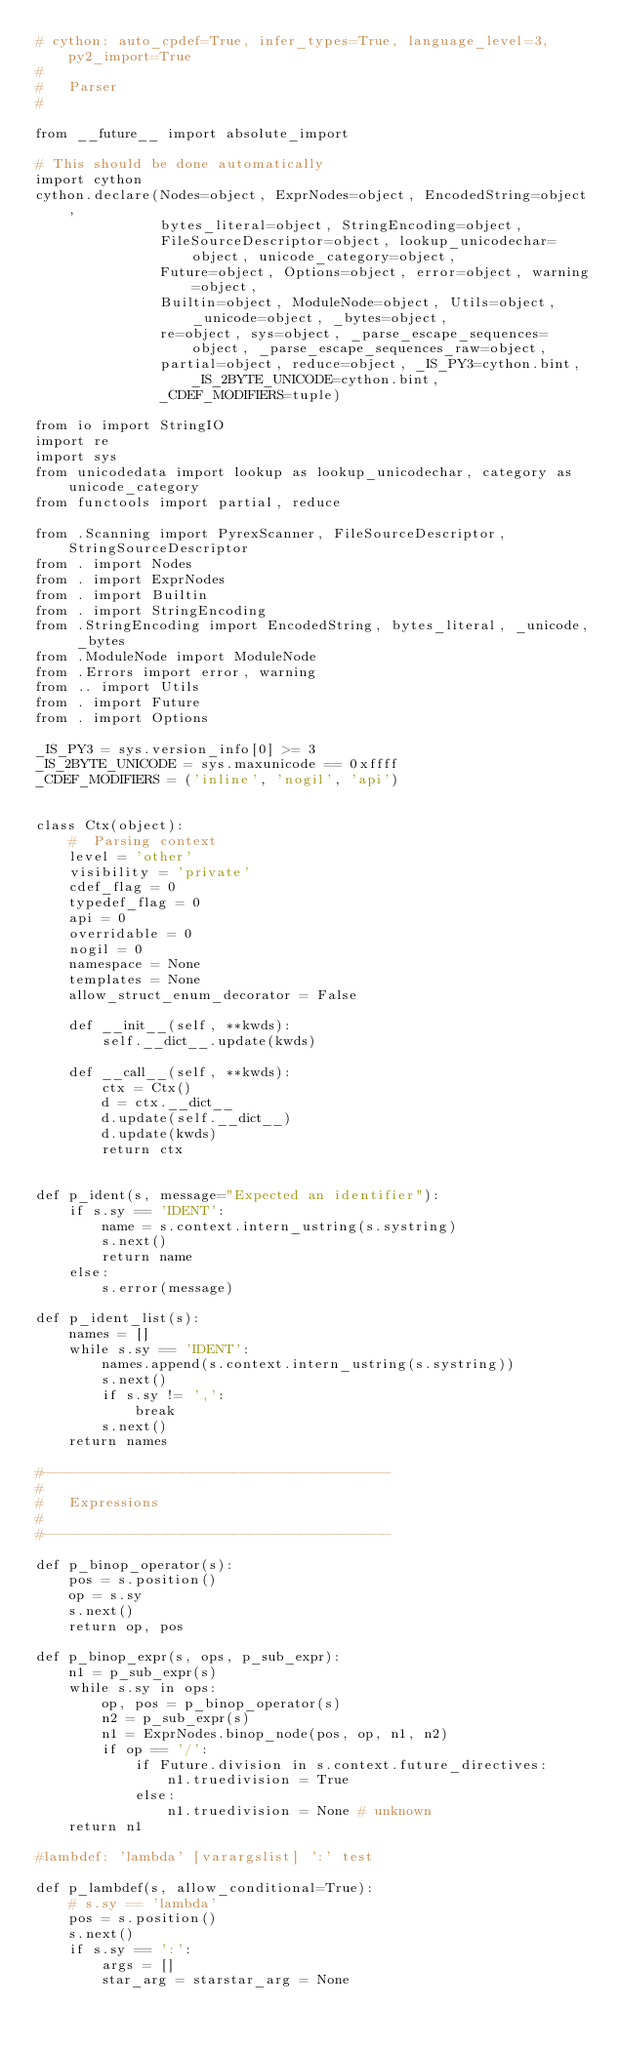Convert code to text. <code><loc_0><loc_0><loc_500><loc_500><_Python_># cython: auto_cpdef=True, infer_types=True, language_level=3, py2_import=True
#
#   Parser
#

from __future__ import absolute_import

# This should be done automatically
import cython
cython.declare(Nodes=object, ExprNodes=object, EncodedString=object,
               bytes_literal=object, StringEncoding=object,
               FileSourceDescriptor=object, lookup_unicodechar=object, unicode_category=object,
               Future=object, Options=object, error=object, warning=object,
               Builtin=object, ModuleNode=object, Utils=object, _unicode=object, _bytes=object,
               re=object, sys=object, _parse_escape_sequences=object, _parse_escape_sequences_raw=object,
               partial=object, reduce=object, _IS_PY3=cython.bint, _IS_2BYTE_UNICODE=cython.bint,
               _CDEF_MODIFIERS=tuple)

from io import StringIO
import re
import sys
from unicodedata import lookup as lookup_unicodechar, category as unicode_category
from functools import partial, reduce

from .Scanning import PyrexScanner, FileSourceDescriptor, StringSourceDescriptor
from . import Nodes
from . import ExprNodes
from . import Builtin
from . import StringEncoding
from .StringEncoding import EncodedString, bytes_literal, _unicode, _bytes
from .ModuleNode import ModuleNode
from .Errors import error, warning
from .. import Utils
from . import Future
from . import Options

_IS_PY3 = sys.version_info[0] >= 3
_IS_2BYTE_UNICODE = sys.maxunicode == 0xffff
_CDEF_MODIFIERS = ('inline', 'nogil', 'api')


class Ctx(object):
    #  Parsing context
    level = 'other'
    visibility = 'private'
    cdef_flag = 0
    typedef_flag = 0
    api = 0
    overridable = 0
    nogil = 0
    namespace = None
    templates = None
    allow_struct_enum_decorator = False

    def __init__(self, **kwds):
        self.__dict__.update(kwds)

    def __call__(self, **kwds):
        ctx = Ctx()
        d = ctx.__dict__
        d.update(self.__dict__)
        d.update(kwds)
        return ctx


def p_ident(s, message="Expected an identifier"):
    if s.sy == 'IDENT':
        name = s.context.intern_ustring(s.systring)
        s.next()
        return name
    else:
        s.error(message)

def p_ident_list(s):
    names = []
    while s.sy == 'IDENT':
        names.append(s.context.intern_ustring(s.systring))
        s.next()
        if s.sy != ',':
            break
        s.next()
    return names

#------------------------------------------
#
#   Expressions
#
#------------------------------------------

def p_binop_operator(s):
    pos = s.position()
    op = s.sy
    s.next()
    return op, pos

def p_binop_expr(s, ops, p_sub_expr):
    n1 = p_sub_expr(s)
    while s.sy in ops:
        op, pos = p_binop_operator(s)
        n2 = p_sub_expr(s)
        n1 = ExprNodes.binop_node(pos, op, n1, n2)
        if op == '/':
            if Future.division in s.context.future_directives:
                n1.truedivision = True
            else:
                n1.truedivision = None # unknown
    return n1

#lambdef: 'lambda' [varargslist] ':' test

def p_lambdef(s, allow_conditional=True):
    # s.sy == 'lambda'
    pos = s.position()
    s.next()
    if s.sy == ':':
        args = []
        star_arg = starstar_arg = None</code> 